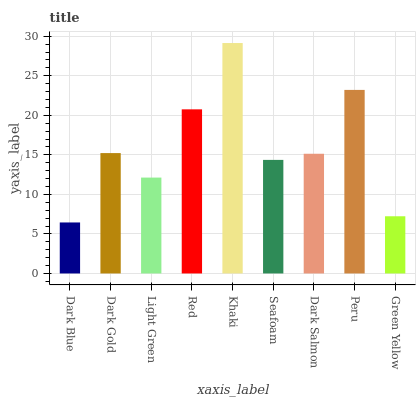Is Dark Gold the minimum?
Answer yes or no. No. Is Dark Gold the maximum?
Answer yes or no. No. Is Dark Gold greater than Dark Blue?
Answer yes or no. Yes. Is Dark Blue less than Dark Gold?
Answer yes or no. Yes. Is Dark Blue greater than Dark Gold?
Answer yes or no. No. Is Dark Gold less than Dark Blue?
Answer yes or no. No. Is Dark Salmon the high median?
Answer yes or no. Yes. Is Dark Salmon the low median?
Answer yes or no. Yes. Is Seafoam the high median?
Answer yes or no. No. Is Light Green the low median?
Answer yes or no. No. 